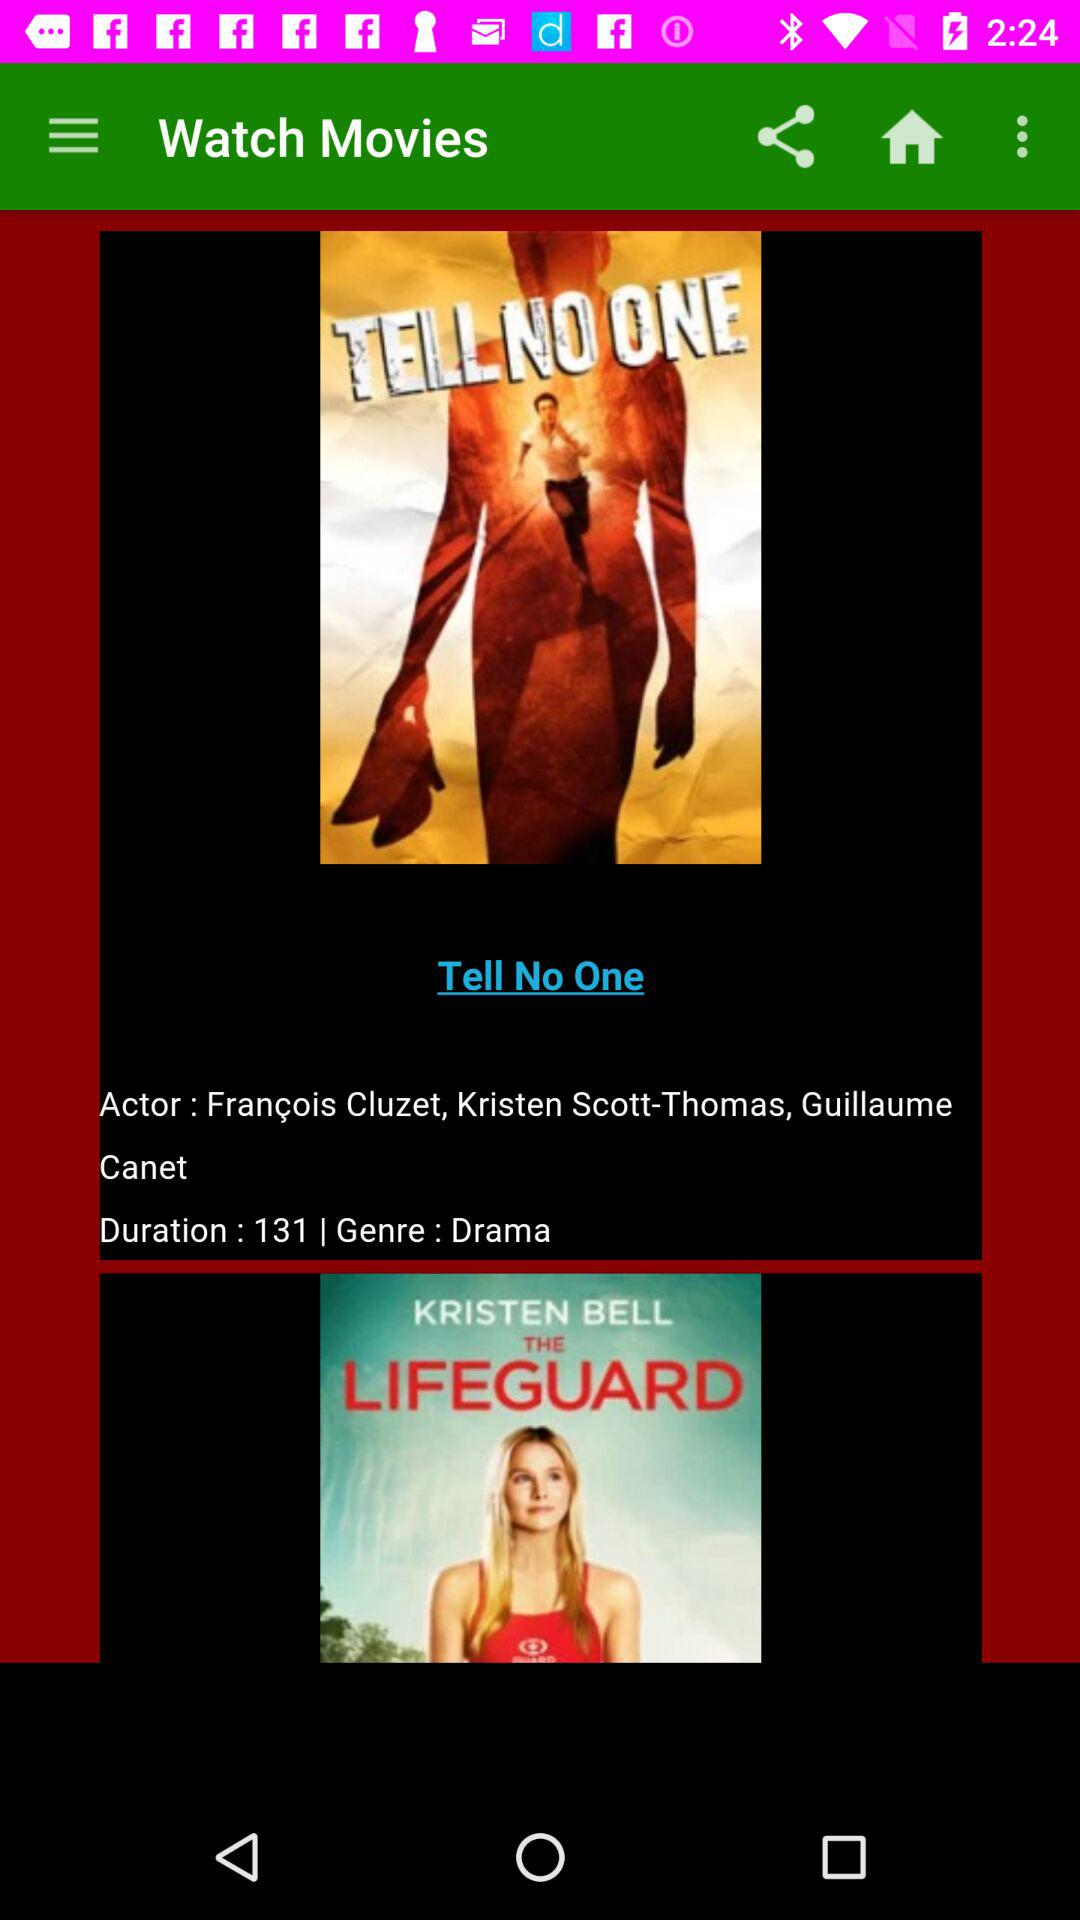What are the actors' names? The actors' names are Francois Cluzet, Kristen Scott-Thomas and Guillaume Canet. 